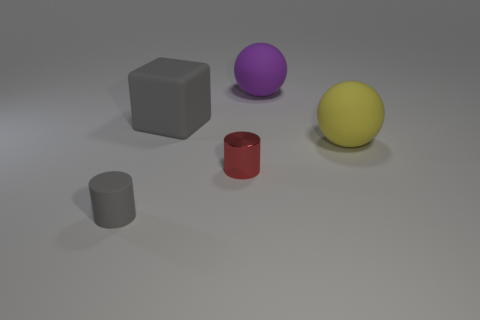Add 4 large green matte cylinders. How many objects exist? 9 Subtract all large red metal objects. Subtract all gray cylinders. How many objects are left? 4 Add 5 large gray objects. How many large gray objects are left? 6 Add 4 small gray matte things. How many small gray matte things exist? 5 Subtract 0 gray balls. How many objects are left? 5 Subtract all cylinders. How many objects are left? 3 Subtract 1 spheres. How many spheres are left? 1 Subtract all blue cubes. Subtract all gray spheres. How many cubes are left? 1 Subtract all red blocks. How many gray spheres are left? 0 